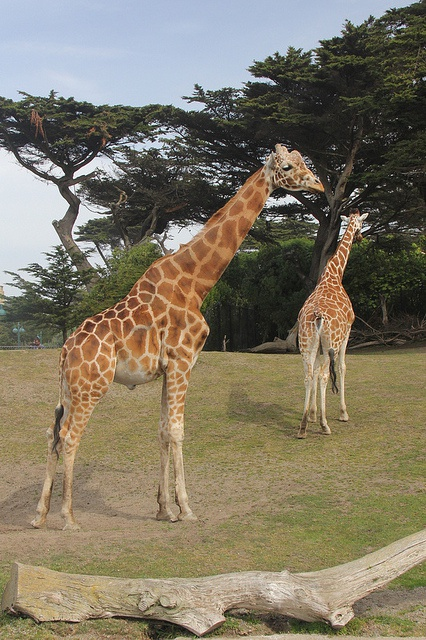Describe the objects in this image and their specific colors. I can see giraffe in lavender, tan, gray, and brown tones and giraffe in lavender, tan, gray, and brown tones in this image. 